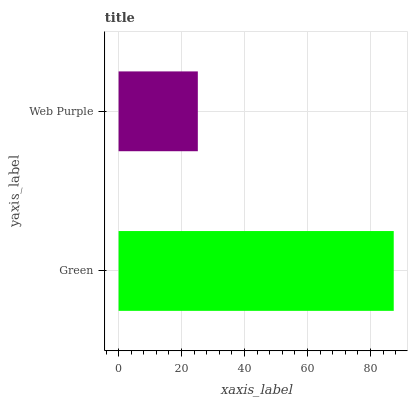Is Web Purple the minimum?
Answer yes or no. Yes. Is Green the maximum?
Answer yes or no. Yes. Is Web Purple the maximum?
Answer yes or no. No. Is Green greater than Web Purple?
Answer yes or no. Yes. Is Web Purple less than Green?
Answer yes or no. Yes. Is Web Purple greater than Green?
Answer yes or no. No. Is Green less than Web Purple?
Answer yes or no. No. Is Green the high median?
Answer yes or no. Yes. Is Web Purple the low median?
Answer yes or no. Yes. Is Web Purple the high median?
Answer yes or no. No. Is Green the low median?
Answer yes or no. No. 